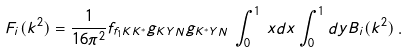<formula> <loc_0><loc_0><loc_500><loc_500>F _ { i } ( k ^ { 2 } ) = \frac { 1 } { 1 6 \pi ^ { 2 } } f _ { f _ { 1 } K K ^ { * } } g _ { K Y N } g _ { K ^ { * } Y N } \, \int _ { 0 } ^ { 1 } \, x d x \int _ { 0 } ^ { 1 } d y B _ { i } ( k ^ { 2 } ) \, .</formula> 